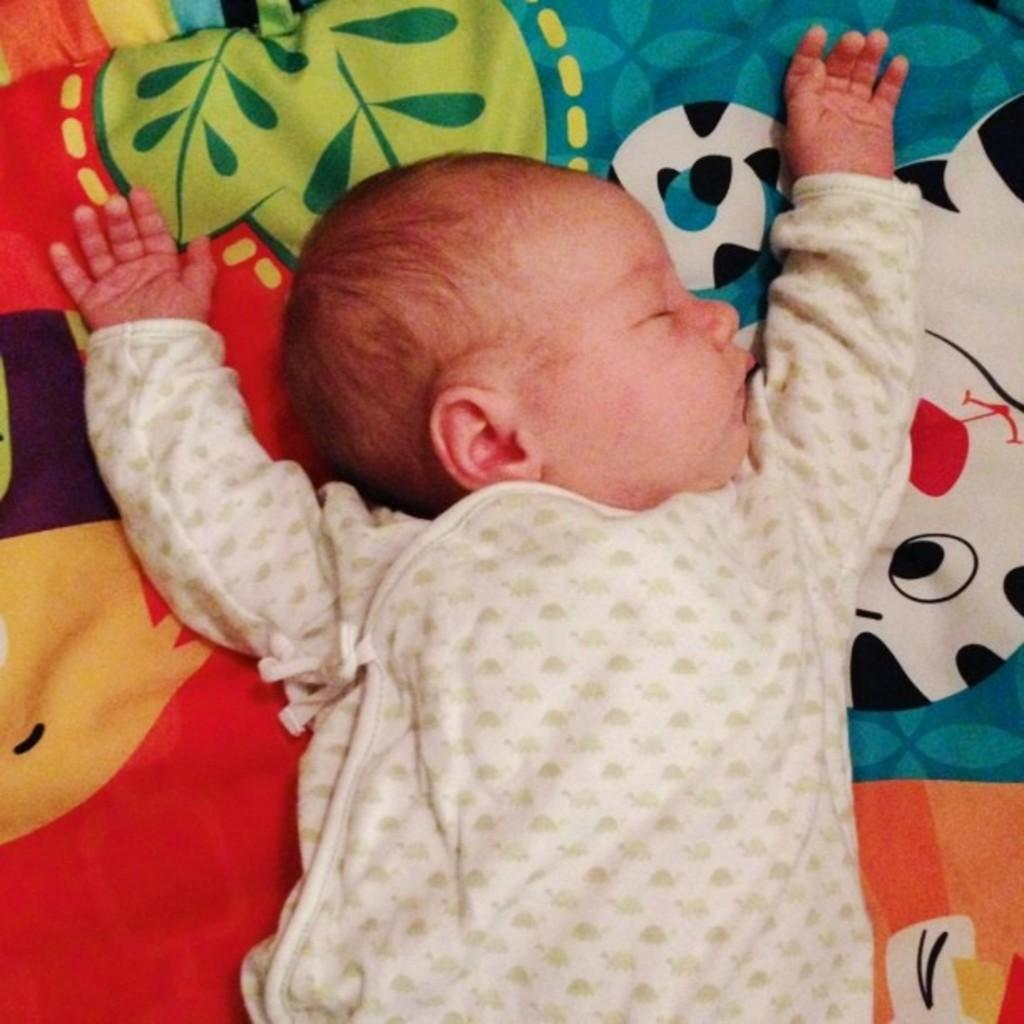What is the main subject of the picture? The main subject of the picture is a baby. What can be seen in the background of the picture? There appears to be a bed in the background of the picture. How many pets are visible in the picture? There are no pets visible in the picture; it features a baby and a bed in the background. What type of bear can be seen interacting with the baby in the picture? There is no bear present in the picture; it only features a baby and a bed in the background. 